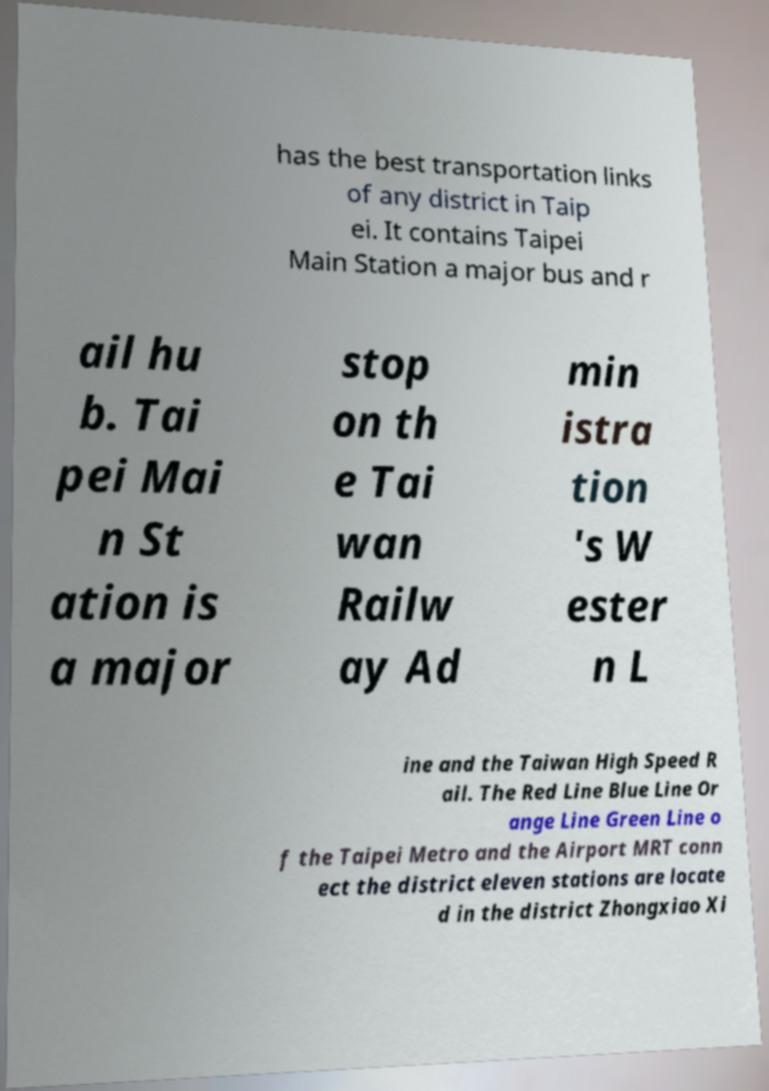What messages or text are displayed in this image? I need them in a readable, typed format. has the best transportation links of any district in Taip ei. It contains Taipei Main Station a major bus and r ail hu b. Tai pei Mai n St ation is a major stop on th e Tai wan Railw ay Ad min istra tion 's W ester n L ine and the Taiwan High Speed R ail. The Red Line Blue Line Or ange Line Green Line o f the Taipei Metro and the Airport MRT conn ect the district eleven stations are locate d in the district Zhongxiao Xi 